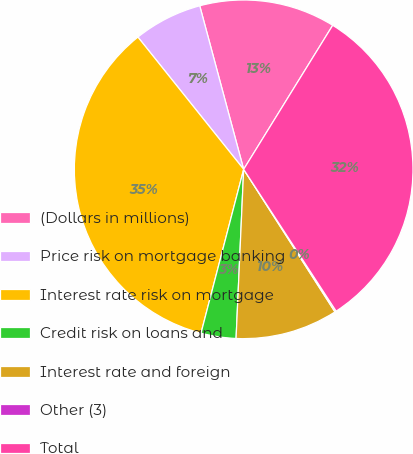Convert chart to OTSL. <chart><loc_0><loc_0><loc_500><loc_500><pie_chart><fcel>(Dollars in millions)<fcel>Price risk on mortgage banking<fcel>Interest rate risk on mortgage<fcel>Credit risk on loans and<fcel>Interest rate and foreign<fcel>Other (3)<fcel>Total<nl><fcel>12.99%<fcel>6.56%<fcel>35.21%<fcel>3.34%<fcel>9.78%<fcel>0.13%<fcel>31.99%<nl></chart> 